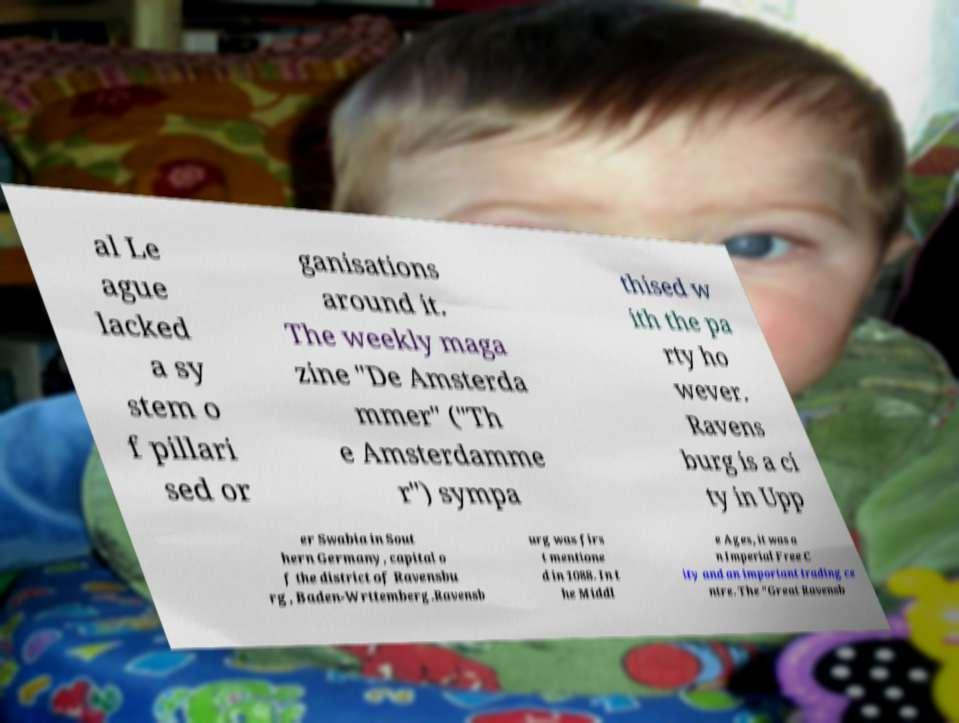Please identify and transcribe the text found in this image. al Le ague lacked a sy stem o f pillari sed or ganisations around it. The weekly maga zine "De Amsterda mmer" ("Th e Amsterdamme r") sympa thised w ith the pa rty ho wever. Ravens burg is a ci ty in Upp er Swabia in Sout hern Germany, capital o f the district of Ravensbu rg, Baden-Wrttemberg.Ravensb urg was firs t mentione d in 1088. In t he Middl e Ages, it was a n Imperial Free C ity and an important trading ce ntre. The "Great Ravensb 